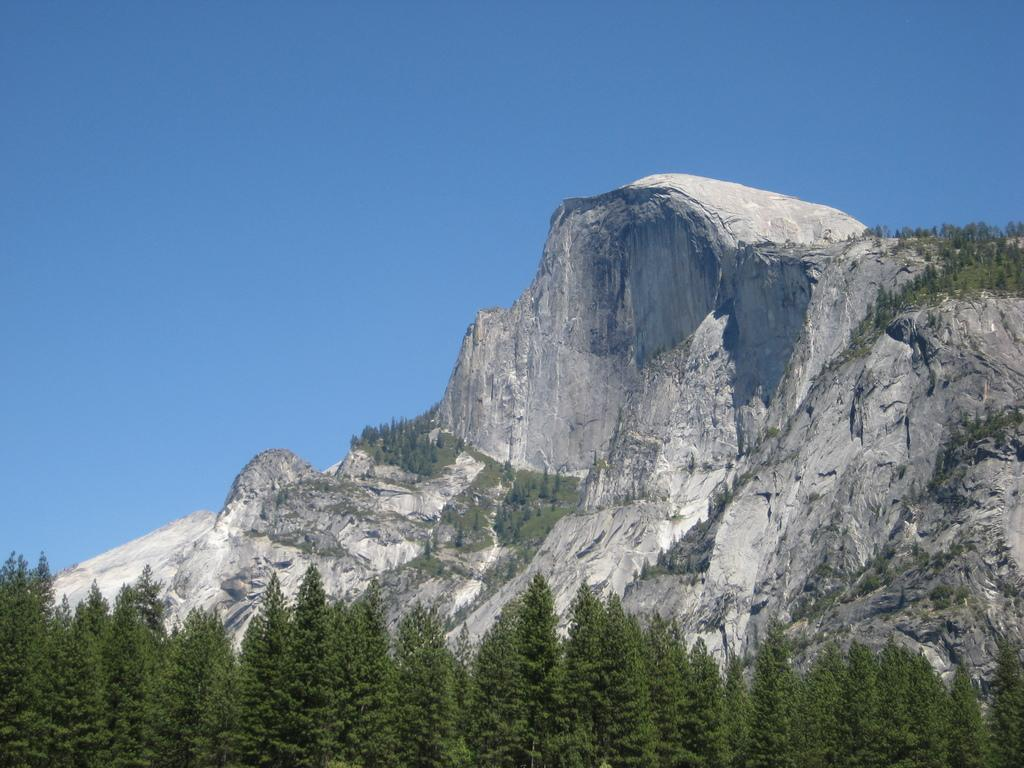What type of vegetation is at the bottom of the image? There are trees at the bottom of the image. What geographical feature can be seen in the background of the image? There is a hill visible in the background of the image. What part of the natural environment is visible in the background of the image? The sky is visible in the background of the image. How many cards are being played on the hill in the image? There are no cards or indication of a game being played in the image. What type of shoes are the trees wearing in the image? Trees do not wear shoes, as they are not living beings capable of wearing footwear. 